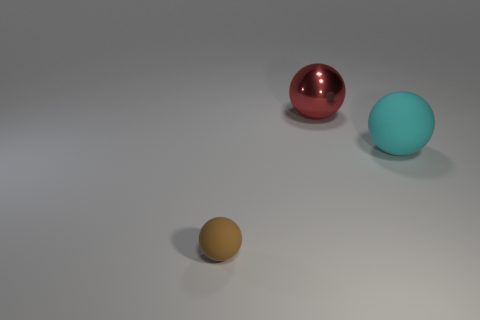There is a object behind the big thing that is on the right side of the large metal sphere; how big is it?
Provide a short and direct response. Large. There is another red thing that is the same shape as the small rubber object; what material is it?
Give a very brief answer. Metal. How many objects are the same size as the red ball?
Provide a succinct answer. 1. Is the size of the metal ball the same as the cyan matte object?
Ensure brevity in your answer.  Yes. What is the size of the thing that is on the left side of the large cyan sphere and right of the brown matte ball?
Provide a short and direct response. Large. Are there more rubber spheres to the right of the small object than tiny balls that are behind the large red object?
Offer a terse response. Yes. What color is the large rubber object that is the same shape as the large shiny thing?
Make the answer very short. Cyan. Is the color of the large object that is to the left of the cyan rubber thing the same as the tiny object?
Make the answer very short. No. What number of small brown metallic objects are there?
Keep it short and to the point. 0. Are the object that is to the right of the red shiny thing and the small object made of the same material?
Your response must be concise. Yes. 